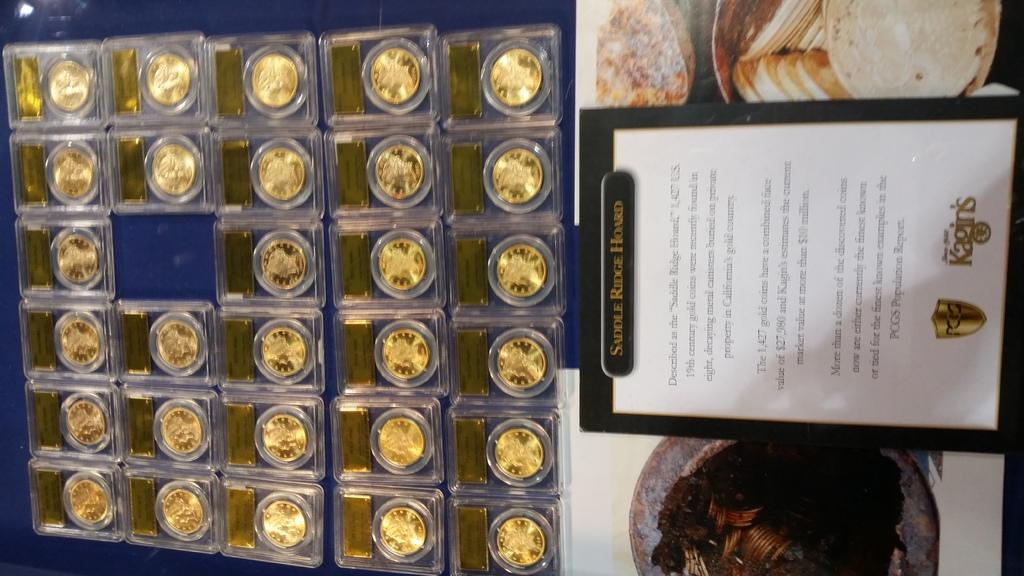Provide a one-sentence caption for the provided image. Saddle ridge Hoard in a picture frame that includes coins. 